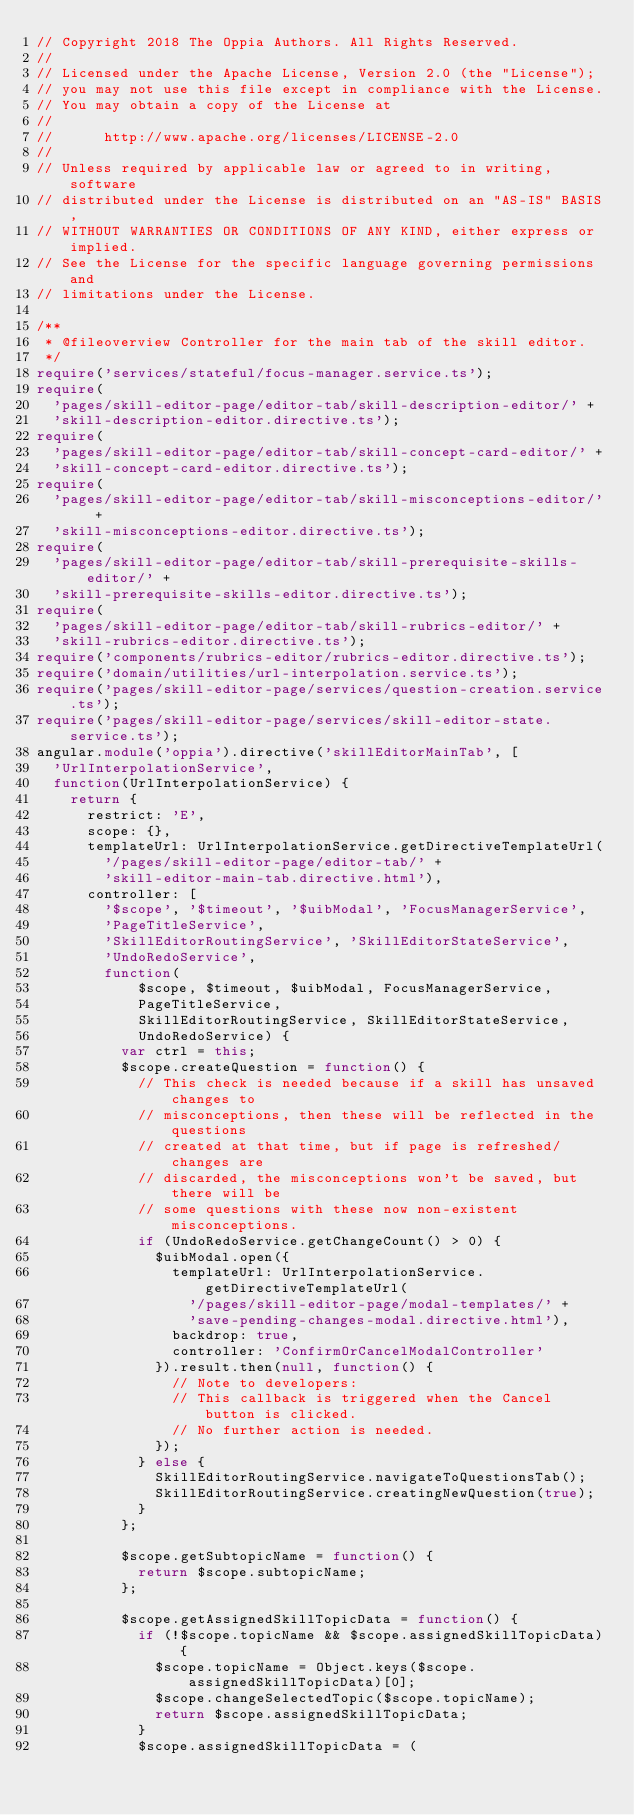<code> <loc_0><loc_0><loc_500><loc_500><_TypeScript_>// Copyright 2018 The Oppia Authors. All Rights Reserved.
//
// Licensed under the Apache License, Version 2.0 (the "License");
// you may not use this file except in compliance with the License.
// You may obtain a copy of the License at
//
//      http://www.apache.org/licenses/LICENSE-2.0
//
// Unless required by applicable law or agreed to in writing, software
// distributed under the License is distributed on an "AS-IS" BASIS,
// WITHOUT WARRANTIES OR CONDITIONS OF ANY KIND, either express or implied.
// See the License for the specific language governing permissions and
// limitations under the License.

/**
 * @fileoverview Controller for the main tab of the skill editor.
 */
require('services/stateful/focus-manager.service.ts');
require(
  'pages/skill-editor-page/editor-tab/skill-description-editor/' +
  'skill-description-editor.directive.ts');
require(
  'pages/skill-editor-page/editor-tab/skill-concept-card-editor/' +
  'skill-concept-card-editor.directive.ts');
require(
  'pages/skill-editor-page/editor-tab/skill-misconceptions-editor/' +
  'skill-misconceptions-editor.directive.ts');
require(
  'pages/skill-editor-page/editor-tab/skill-prerequisite-skills-editor/' +
  'skill-prerequisite-skills-editor.directive.ts');
require(
  'pages/skill-editor-page/editor-tab/skill-rubrics-editor/' +
  'skill-rubrics-editor.directive.ts');
require('components/rubrics-editor/rubrics-editor.directive.ts');
require('domain/utilities/url-interpolation.service.ts');
require('pages/skill-editor-page/services/question-creation.service.ts');
require('pages/skill-editor-page/services/skill-editor-state.service.ts');
angular.module('oppia').directive('skillEditorMainTab', [
  'UrlInterpolationService',
  function(UrlInterpolationService) {
    return {
      restrict: 'E',
      scope: {},
      templateUrl: UrlInterpolationService.getDirectiveTemplateUrl(
        '/pages/skill-editor-page/editor-tab/' +
        'skill-editor-main-tab.directive.html'),
      controller: [
        '$scope', '$timeout', '$uibModal', 'FocusManagerService',
        'PageTitleService',
        'SkillEditorRoutingService', 'SkillEditorStateService',
        'UndoRedoService',
        function(
            $scope, $timeout, $uibModal, FocusManagerService,
            PageTitleService,
            SkillEditorRoutingService, SkillEditorStateService,
            UndoRedoService) {
          var ctrl = this;
          $scope.createQuestion = function() {
            // This check is needed because if a skill has unsaved changes to
            // misconceptions, then these will be reflected in the questions
            // created at that time, but if page is refreshed/changes are
            // discarded, the misconceptions won't be saved, but there will be
            // some questions with these now non-existent misconceptions.
            if (UndoRedoService.getChangeCount() > 0) {
              $uibModal.open({
                templateUrl: UrlInterpolationService.getDirectiveTemplateUrl(
                  '/pages/skill-editor-page/modal-templates/' +
                  'save-pending-changes-modal.directive.html'),
                backdrop: true,
                controller: 'ConfirmOrCancelModalController'
              }).result.then(null, function() {
                // Note to developers:
                // This callback is triggered when the Cancel button is clicked.
                // No further action is needed.
              });
            } else {
              SkillEditorRoutingService.navigateToQuestionsTab();
              SkillEditorRoutingService.creatingNewQuestion(true);
            }
          };

          $scope.getSubtopicName = function() {
            return $scope.subtopicName;
          };

          $scope.getAssignedSkillTopicData = function() {
            if (!$scope.topicName && $scope.assignedSkillTopicData) {
              $scope.topicName = Object.keys($scope.assignedSkillTopicData)[0];
              $scope.changeSelectedTopic($scope.topicName);
              return $scope.assignedSkillTopicData;
            }
            $scope.assignedSkillTopicData = (</code> 